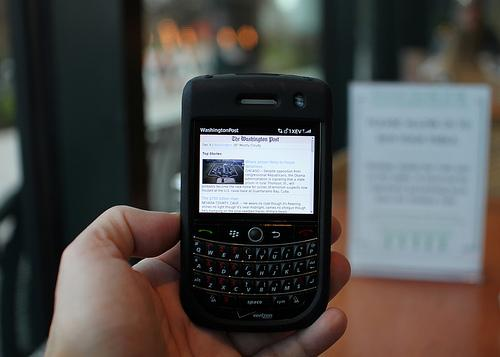Observe the image and count the total number of buttons on the cell phone. There are ten buttons on the cell phone. Examine the image and tell me who is holding the cellphone. A person is holding a black phone in their hand. Point out the part of the cell phone where a person can listen to the caller's voice. The earpiece of the cell phone is the part where a person can listen to the caller's voice. Investigate the image and mention the features of the cell phone's front camera. The front camera of the cell phone is small and black. Explain what can be seen on the cell phone's screen. On the cell phone's screen, there are white letters and a picture with a white background. Analyze the image and describe the keyboard on the black phone. The keyboard on the black phone is small, black, and red with white letters. In the image, what is the color of the screen on the black phone? The screen on the black phone is white. What color are the buttons on the cell phone? The buttons on the cell phone are black, red, and green. Identify the brand logo displayed on the phone. The logo displayed on the phone is that of Verizon. Look at the image and determine which finger is closest to a button on the phone. A person's pinky finger is closest to a button on the phone. What is the make and color of the phone in the image? Black phone with Verizon logo. What is the emotional feeling associated with this image? Neutral Explain the interaction between the person and the phone in the image. A person is holding the phone with their fingers on the edges. Find the referential phrase that represents the green button on the cell phone. "Green button on phone." Rate the quality of the image on a scale of 1 to 10, where 1 is very poor, and 10 is excellent. 8 Describe the main object of the image. A black cell phone with touch screen and buttons. Explain the relationship between the letters on the screen and the screen of the cell phone. Letters are printed on the screen of the cell phone. What is the size of the smallest button on the cell phone? Width: 15 Height: 15 Which button is larger: the green button or the red button? Green button Outline the segments in the image that represent the screen of the black phone. X:194 Y:124 Width:121 Height:121 What is being displayed on the cell phone's screen? White background and black text. What is the subject matter of the picture on the black phone's screen? Unable to determine. Identify the text found in the white sign with black text. Unable to perform OCR. Which part of a person is visible in the image? Hand What color is the button beside the green button on the cellphone? Red List the attributes of the cell phone in the image. Black, touch screen, red and green buttons, Verizon logo, front camera. Describe the keyboard on the phone. Small black and red cellphone keyboard. Identify the brand logo present within the image. Verizon logo Identify any unusual or unexpected objects in the image. There are no anomalies detected. 